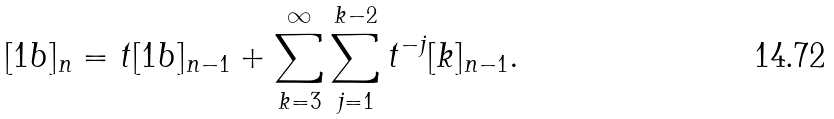<formula> <loc_0><loc_0><loc_500><loc_500>[ 1 b ] _ { n } = t [ 1 b ] _ { n - 1 } + \sum _ { k = 3 } ^ { \infty } \sum _ { j = 1 } ^ { k - 2 } t ^ { - j } [ k ] _ { n - 1 } .</formula> 